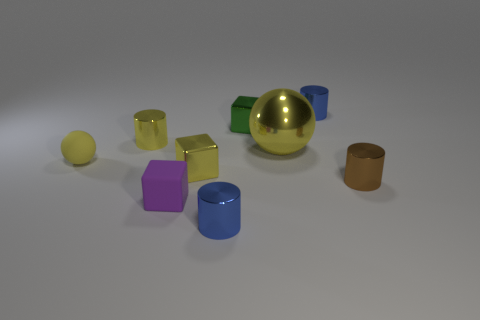Subtract all blue cylinders. Subtract all purple cubes. How many cylinders are left? 2 Add 1 big red matte objects. How many objects exist? 10 Subtract all cylinders. How many objects are left? 5 Add 8 tiny shiny cubes. How many tiny shiny cubes are left? 10 Add 5 brown cylinders. How many brown cylinders exist? 6 Subtract 0 gray spheres. How many objects are left? 9 Subtract all tiny blue shiny cubes. Subtract all purple objects. How many objects are left? 8 